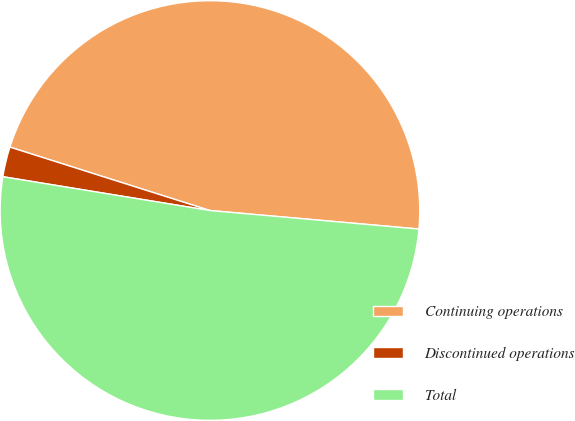Convert chart to OTSL. <chart><loc_0><loc_0><loc_500><loc_500><pie_chart><fcel>Continuing operations<fcel>Discontinued operations<fcel>Total<nl><fcel>46.52%<fcel>2.31%<fcel>51.17%<nl></chart> 